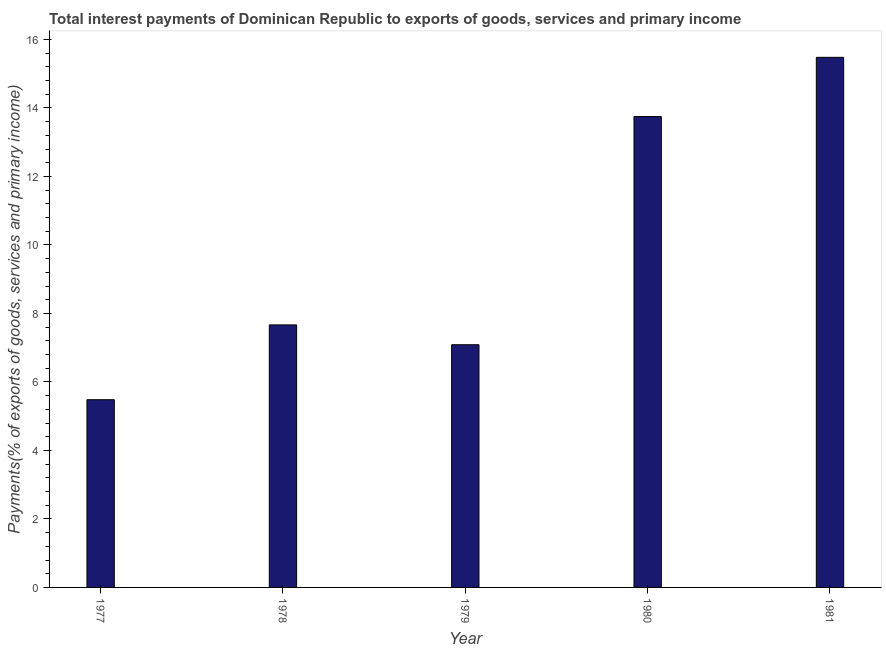Does the graph contain grids?
Offer a terse response. No. What is the title of the graph?
Offer a terse response. Total interest payments of Dominican Republic to exports of goods, services and primary income. What is the label or title of the X-axis?
Make the answer very short. Year. What is the label or title of the Y-axis?
Keep it short and to the point. Payments(% of exports of goods, services and primary income). What is the total interest payments on external debt in 1978?
Your answer should be compact. 7.67. Across all years, what is the maximum total interest payments on external debt?
Provide a short and direct response. 15.48. Across all years, what is the minimum total interest payments on external debt?
Offer a terse response. 5.48. In which year was the total interest payments on external debt minimum?
Your answer should be compact. 1977. What is the sum of the total interest payments on external debt?
Give a very brief answer. 49.46. What is the difference between the total interest payments on external debt in 1980 and 1981?
Your answer should be very brief. -1.73. What is the average total interest payments on external debt per year?
Provide a short and direct response. 9.89. What is the median total interest payments on external debt?
Your answer should be compact. 7.67. In how many years, is the total interest payments on external debt greater than 10 %?
Your answer should be compact. 2. What is the ratio of the total interest payments on external debt in 1978 to that in 1979?
Offer a very short reply. 1.08. Is the total interest payments on external debt in 1977 less than that in 1981?
Your answer should be compact. Yes. Is the difference between the total interest payments on external debt in 1979 and 1980 greater than the difference between any two years?
Your answer should be compact. No. What is the difference between the highest and the second highest total interest payments on external debt?
Your answer should be compact. 1.73. What is the difference between the highest and the lowest total interest payments on external debt?
Your answer should be compact. 10. In how many years, is the total interest payments on external debt greater than the average total interest payments on external debt taken over all years?
Offer a terse response. 2. How many bars are there?
Ensure brevity in your answer.  5. Are all the bars in the graph horizontal?
Make the answer very short. No. What is the Payments(% of exports of goods, services and primary income) in 1977?
Make the answer very short. 5.48. What is the Payments(% of exports of goods, services and primary income) of 1978?
Give a very brief answer. 7.67. What is the Payments(% of exports of goods, services and primary income) of 1979?
Keep it short and to the point. 7.09. What is the Payments(% of exports of goods, services and primary income) of 1980?
Offer a terse response. 13.75. What is the Payments(% of exports of goods, services and primary income) of 1981?
Provide a succinct answer. 15.48. What is the difference between the Payments(% of exports of goods, services and primary income) in 1977 and 1978?
Ensure brevity in your answer.  -2.18. What is the difference between the Payments(% of exports of goods, services and primary income) in 1977 and 1979?
Your response must be concise. -1.61. What is the difference between the Payments(% of exports of goods, services and primary income) in 1977 and 1980?
Make the answer very short. -8.27. What is the difference between the Payments(% of exports of goods, services and primary income) in 1977 and 1981?
Offer a very short reply. -10. What is the difference between the Payments(% of exports of goods, services and primary income) in 1978 and 1979?
Your answer should be compact. 0.58. What is the difference between the Payments(% of exports of goods, services and primary income) in 1978 and 1980?
Your response must be concise. -6.08. What is the difference between the Payments(% of exports of goods, services and primary income) in 1978 and 1981?
Ensure brevity in your answer.  -7.81. What is the difference between the Payments(% of exports of goods, services and primary income) in 1979 and 1980?
Your answer should be very brief. -6.66. What is the difference between the Payments(% of exports of goods, services and primary income) in 1979 and 1981?
Ensure brevity in your answer.  -8.39. What is the difference between the Payments(% of exports of goods, services and primary income) in 1980 and 1981?
Your answer should be compact. -1.73. What is the ratio of the Payments(% of exports of goods, services and primary income) in 1977 to that in 1978?
Your answer should be compact. 0.71. What is the ratio of the Payments(% of exports of goods, services and primary income) in 1977 to that in 1979?
Keep it short and to the point. 0.77. What is the ratio of the Payments(% of exports of goods, services and primary income) in 1977 to that in 1980?
Your answer should be very brief. 0.4. What is the ratio of the Payments(% of exports of goods, services and primary income) in 1977 to that in 1981?
Provide a succinct answer. 0.35. What is the ratio of the Payments(% of exports of goods, services and primary income) in 1978 to that in 1979?
Offer a terse response. 1.08. What is the ratio of the Payments(% of exports of goods, services and primary income) in 1978 to that in 1980?
Offer a terse response. 0.56. What is the ratio of the Payments(% of exports of goods, services and primary income) in 1978 to that in 1981?
Offer a very short reply. 0.49. What is the ratio of the Payments(% of exports of goods, services and primary income) in 1979 to that in 1980?
Your answer should be compact. 0.52. What is the ratio of the Payments(% of exports of goods, services and primary income) in 1979 to that in 1981?
Give a very brief answer. 0.46. What is the ratio of the Payments(% of exports of goods, services and primary income) in 1980 to that in 1981?
Your response must be concise. 0.89. 